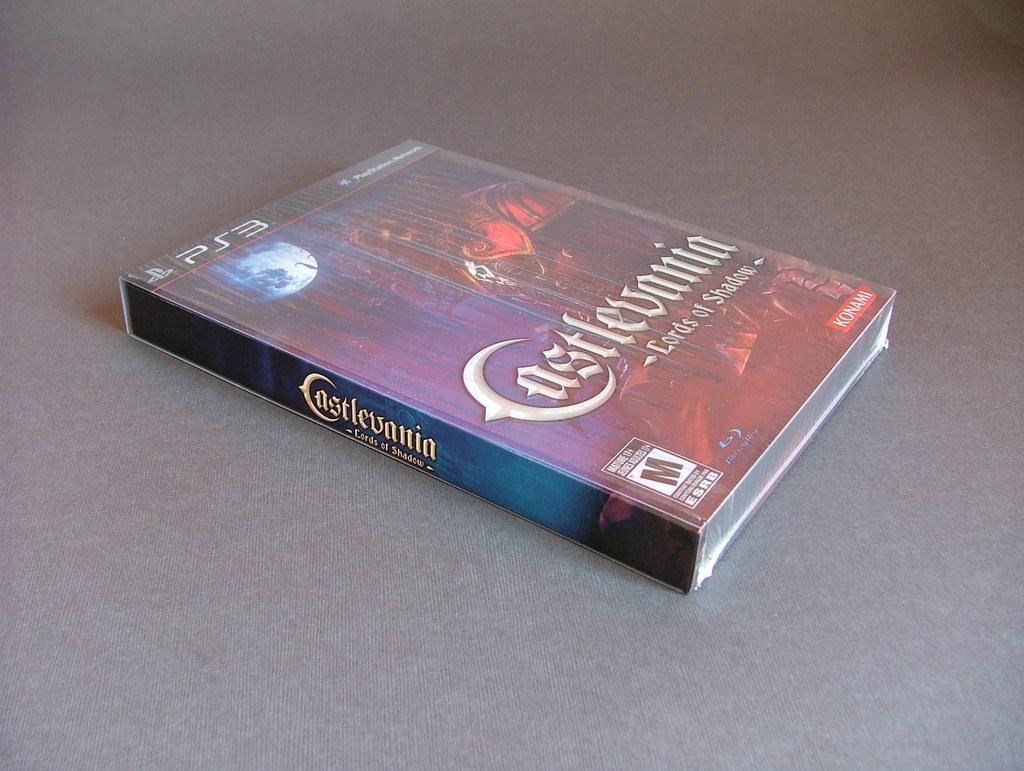<image>
Summarize the visual content of the image. A game case has the Playstation 3 logo in the upper left corner. 